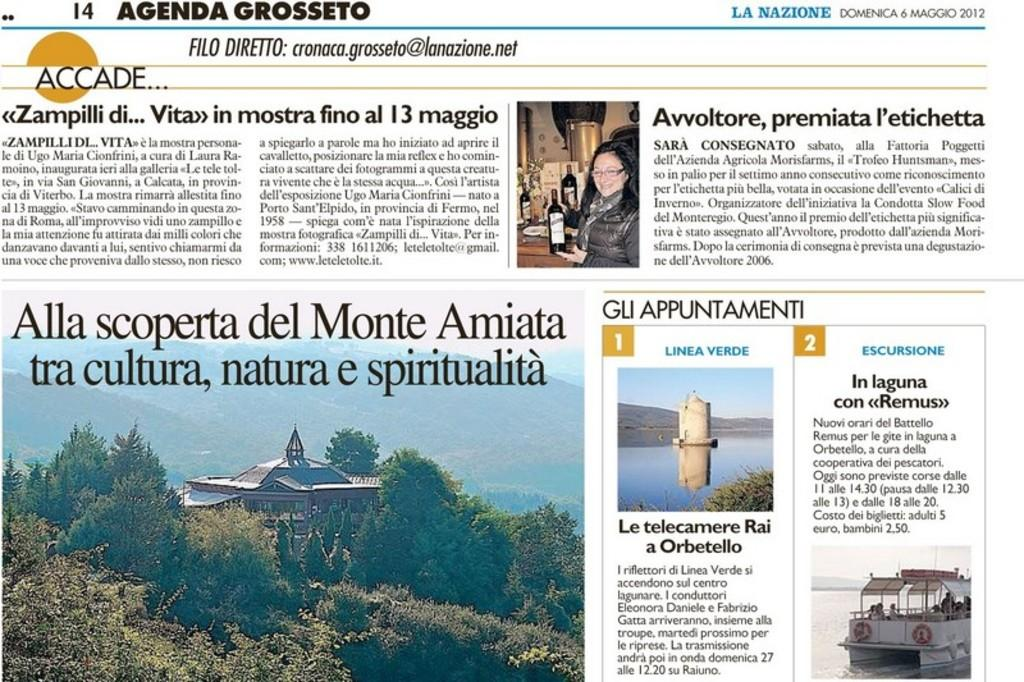<image>
Provide a brief description of the given image. The front page of the Accade newspaper from 2012 